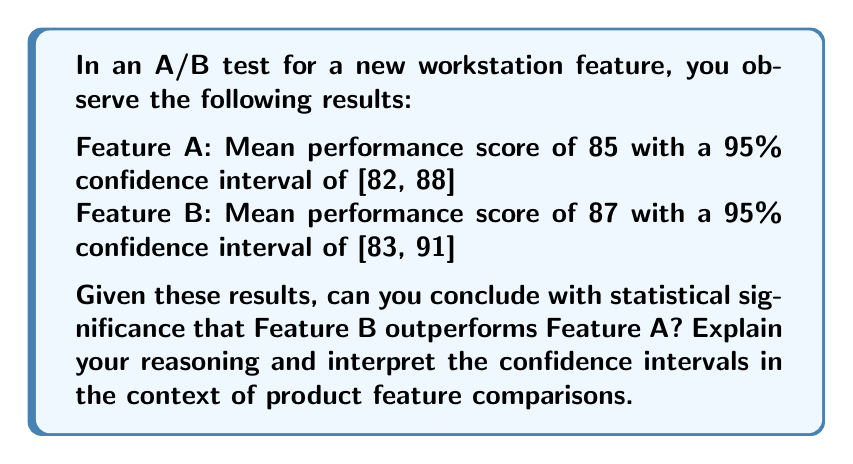Can you answer this question? To determine if Feature B significantly outperforms Feature A, we need to examine the confidence intervals and their overlap:

1. Interpret the confidence intervals:
   - Feature A: 95% CI [82, 88]
   - Feature B: 95% CI [83, 91]

2. Check for overlap:
   The confidence intervals overlap in the range [83, 88].

3. Interpret the overlap:
   When confidence intervals overlap, it indicates that the difference between the two features is not statistically significant at the 95% confidence level.

4. Analyze the implications:
   - The overlap suggests that the true population means for both features could potentially be the same.
   - We cannot conclude with 95% confidence that Feature B is superior to Feature A.

5. Consider practical significance:
   - Feature B has a higher point estimate (87 vs. 85), which may suggest a trend towards better performance.
   - However, the overlap in confidence intervals indicates that this difference could be due to random chance rather than a true performance advantage.

6. Decision making:
   - As a product manager, you cannot claim with statistical certainty that Feature B outperforms Feature A.
   - Further testing or larger sample sizes might be needed to detect a significant difference if one truly exists.

In A/B testing for product features, overlapping confidence intervals indicate that we cannot conclude one feature is significantly better than the other at the given confidence level.
Answer: No, cannot conclude Feature B significantly outperforms Feature A due to overlapping confidence intervals. 